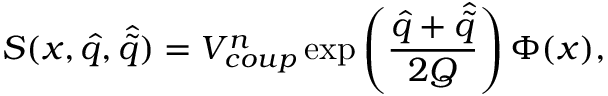<formula> <loc_0><loc_0><loc_500><loc_500>S ( x , \hat { q } , \hat { \tilde { q } } ) = V _ { c o u p } ^ { n } \exp \left ( { \frac { \hat { q } + \hat { \tilde { q } } } { 2 Q } } \right ) \Phi ( x ) ,</formula> 